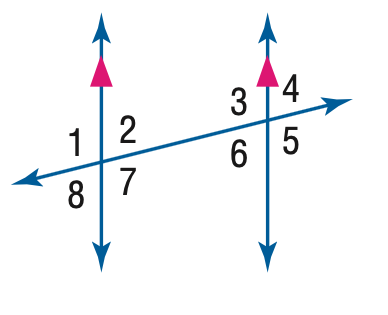Question: In the figure, m \angle 1 = 94. Find the measure of \angle 3.
Choices:
A. 76
B. 86
C. 94
D. 96
Answer with the letter. Answer: C 